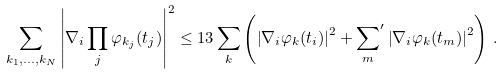Convert formula to latex. <formula><loc_0><loc_0><loc_500><loc_500>\sum _ { k _ { 1 } , \dots , k _ { N } } \left | \nabla _ { i } \prod _ { j } \varphi _ { k _ { j } } ( t _ { j } ) \right | ^ { 2 } \leq 1 3 \sum _ { k } \left ( \left | \nabla _ { i } \varphi _ { k } ( t _ { i } ) \right | ^ { 2 } + { \sum _ { m } } ^ { \prime } \left | \nabla _ { i } \varphi _ { k } ( t _ { m } ) \right | ^ { 2 } \right ) \, .</formula> 